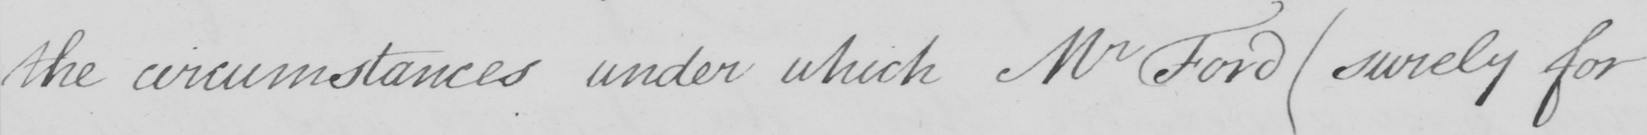Can you tell me what this handwritten text says? the circumstances under which Mr Ford  ( surely for 